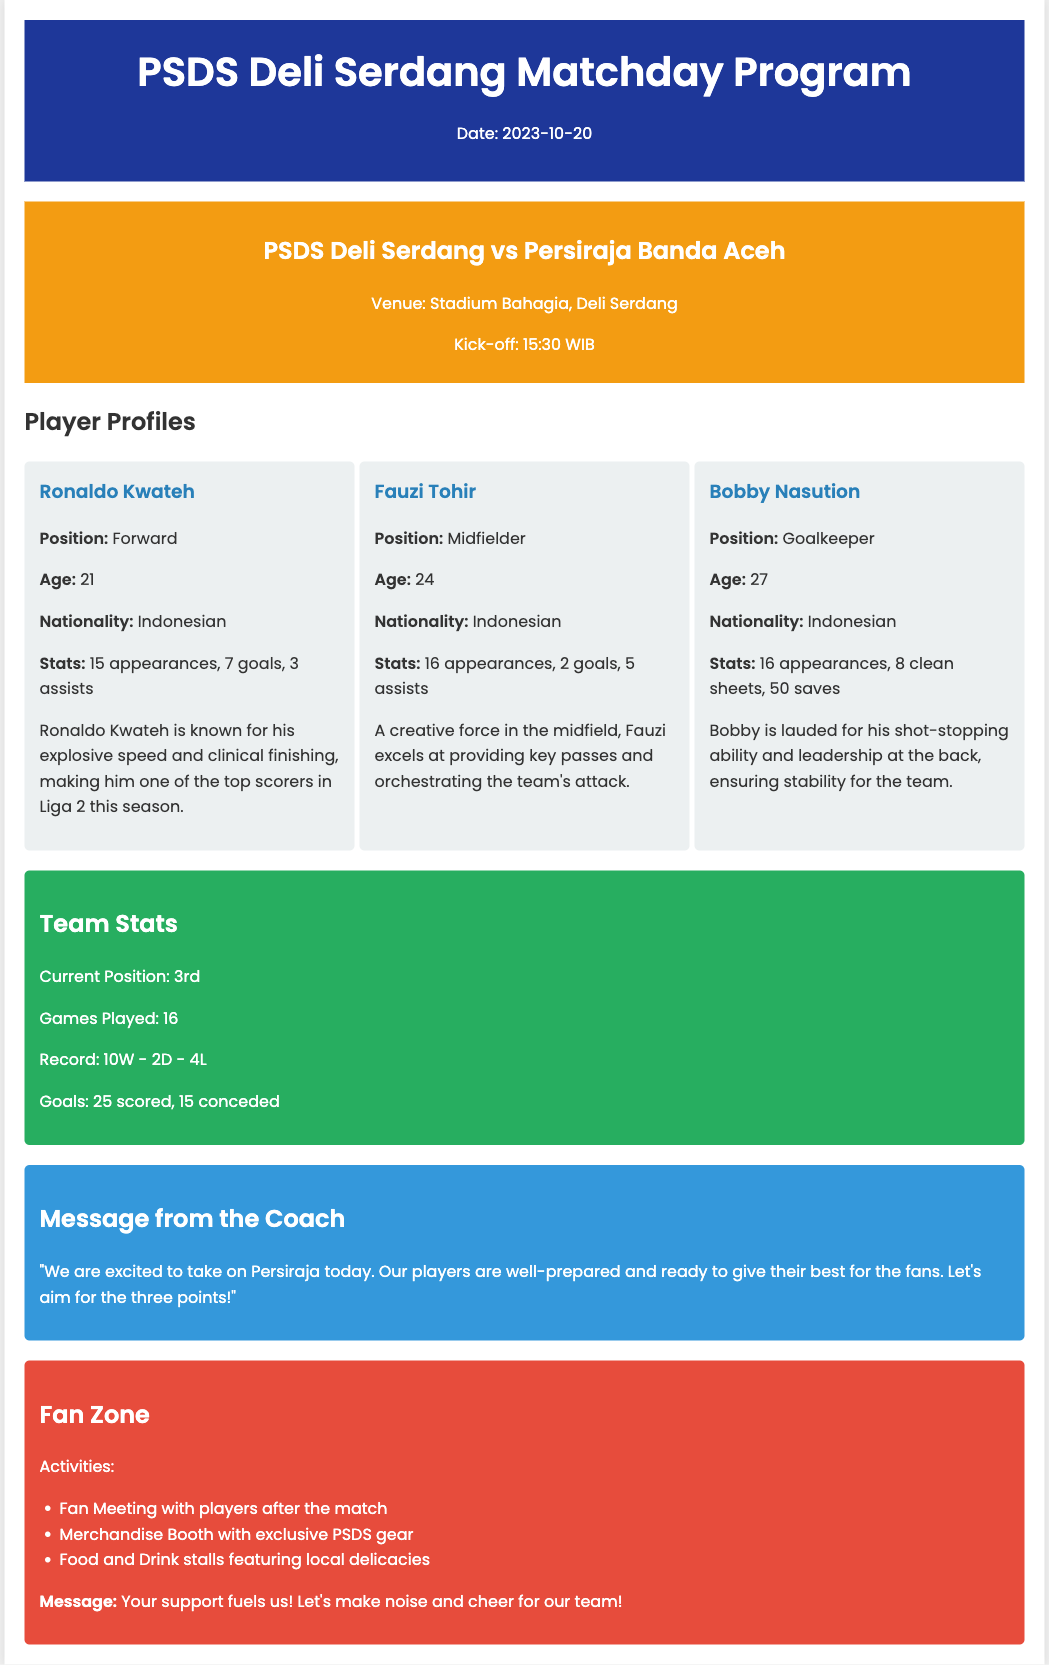What is the match date? The match date is specified in the header of the document.
Answer: 2023-10-20 Who are PSDS Deli Serdang playing against? The opponent of PSDS Deli Serdang is mentioned in the match info section.
Answer: Persiraja Banda Aceh What is Ronaldo Kwateh's position? The position of Ronaldo Kwateh is included in his player profile.
Answer: Forward How many goals has Bobby Nasution kept clean sheets for? The clean sheets for Bobby Nasution is provided in his statistics.
Answer: 8 What is the team's current position in Liga 2? The current position of the team is found in the team stats section.
Answer: 3rd How many assists has Fauzi Tohir recorded? The number of assists for Fauzi Tohir is listed in his profile.
Answer: 5 What message did the coach give? The coach's message is included in its own section in the document.
Answer: "We are excited to take on Persiraja today. Our players are well-prepared and ready to give their best for the fans. Let's aim for the three points!" What activities are mentioned in the Fan Zone? Activities mentioned in the Fan Zone are listed under that section.
Answer: Fan Meeting with players after the match How many games has the team played? The total games played by the team is stated in the team stats section.
Answer: 16 What is a key characteristic of Ronaldo Kwateh mentioned? A notable trait of Ronaldo Kwateh is described in his profile.
Answer: Explosive speed 